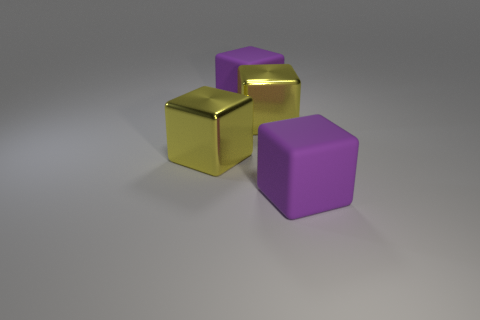Subtract all blue cylinders. How many purple blocks are left? 2 Add 1 large purple blocks. How many objects exist? 5 Subtract all gray cubes. Subtract all brown cylinders. How many cubes are left? 4 Add 2 yellow objects. How many yellow objects are left? 4 Add 3 purple cubes. How many purple cubes exist? 5 Subtract 0 purple spheres. How many objects are left? 4 Subtract all big yellow blocks. Subtract all large rubber cubes. How many objects are left? 0 